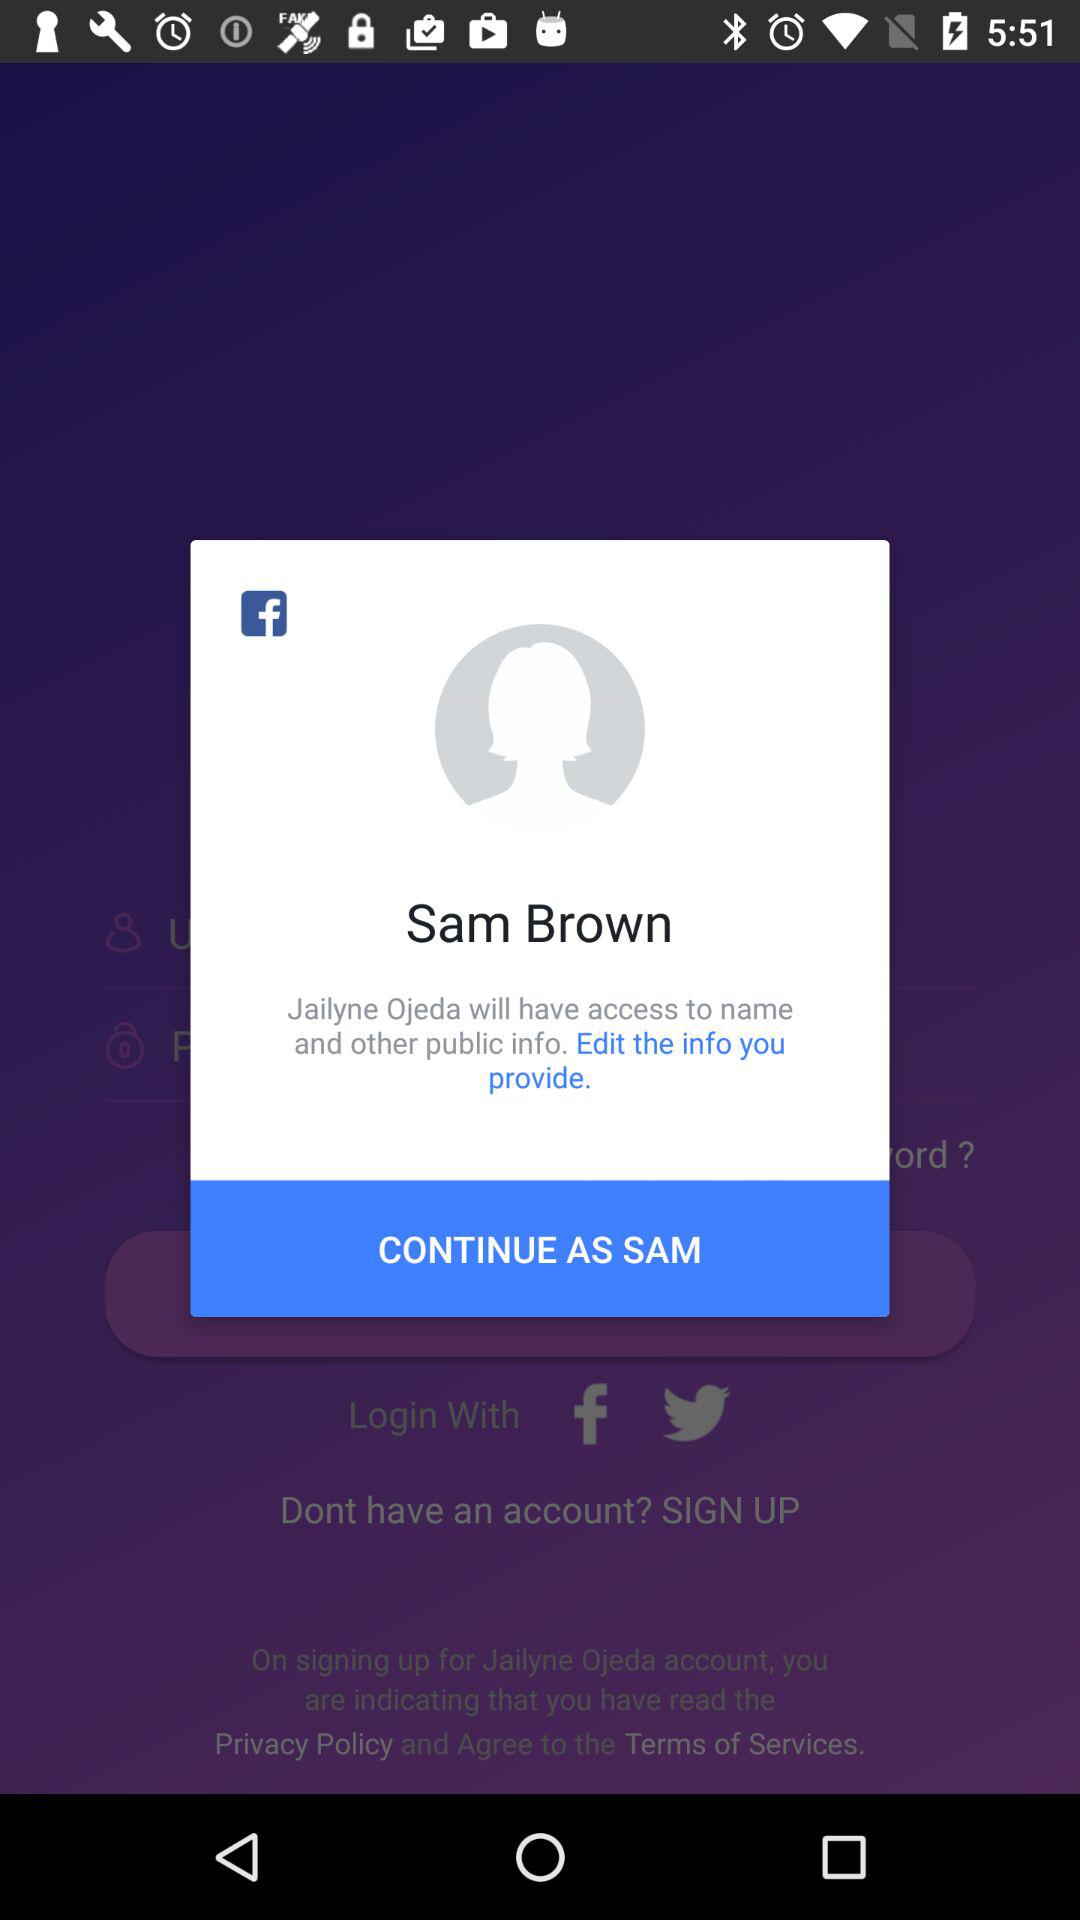What is the user name to continue on the login page? The user name is Sam Brown. 